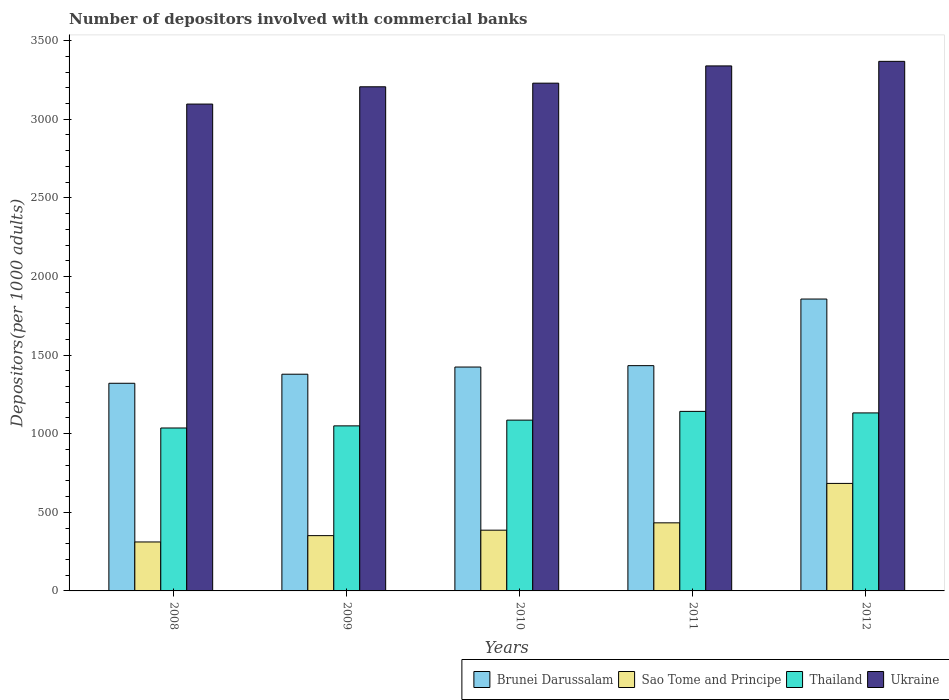How many groups of bars are there?
Your answer should be compact. 5. Are the number of bars per tick equal to the number of legend labels?
Give a very brief answer. Yes. Are the number of bars on each tick of the X-axis equal?
Your answer should be very brief. Yes. What is the label of the 1st group of bars from the left?
Your answer should be compact. 2008. In how many cases, is the number of bars for a given year not equal to the number of legend labels?
Your answer should be compact. 0. What is the number of depositors involved with commercial banks in Ukraine in 2009?
Your answer should be compact. 3206.64. Across all years, what is the maximum number of depositors involved with commercial banks in Brunei Darussalam?
Your answer should be very brief. 1856.6. Across all years, what is the minimum number of depositors involved with commercial banks in Sao Tome and Principe?
Your response must be concise. 311.37. In which year was the number of depositors involved with commercial banks in Thailand maximum?
Offer a very short reply. 2011. What is the total number of depositors involved with commercial banks in Ukraine in the graph?
Offer a very short reply. 1.62e+04. What is the difference between the number of depositors involved with commercial banks in Sao Tome and Principe in 2009 and that in 2010?
Provide a short and direct response. -34.67. What is the difference between the number of depositors involved with commercial banks in Ukraine in 2011 and the number of depositors involved with commercial banks in Brunei Darussalam in 2012?
Your answer should be compact. 1482.81. What is the average number of depositors involved with commercial banks in Brunei Darussalam per year?
Give a very brief answer. 1482.56. In the year 2010, what is the difference between the number of depositors involved with commercial banks in Thailand and number of depositors involved with commercial banks in Ukraine?
Your response must be concise. -2143.33. What is the ratio of the number of depositors involved with commercial banks in Thailand in 2009 to that in 2011?
Offer a very short reply. 0.92. Is the difference between the number of depositors involved with commercial banks in Thailand in 2008 and 2009 greater than the difference between the number of depositors involved with commercial banks in Ukraine in 2008 and 2009?
Offer a terse response. Yes. What is the difference between the highest and the second highest number of depositors involved with commercial banks in Ukraine?
Your answer should be compact. 28.98. What is the difference between the highest and the lowest number of depositors involved with commercial banks in Sao Tome and Principe?
Provide a short and direct response. 372.44. Is the sum of the number of depositors involved with commercial banks in Ukraine in 2010 and 2012 greater than the maximum number of depositors involved with commercial banks in Sao Tome and Principe across all years?
Your answer should be compact. Yes. What does the 1st bar from the left in 2009 represents?
Your answer should be very brief. Brunei Darussalam. What does the 2nd bar from the right in 2012 represents?
Make the answer very short. Thailand. Is it the case that in every year, the sum of the number of depositors involved with commercial banks in Brunei Darussalam and number of depositors involved with commercial banks in Thailand is greater than the number of depositors involved with commercial banks in Sao Tome and Principe?
Provide a succinct answer. Yes. What is the difference between two consecutive major ticks on the Y-axis?
Give a very brief answer. 500. Where does the legend appear in the graph?
Give a very brief answer. Bottom right. How many legend labels are there?
Make the answer very short. 4. How are the legend labels stacked?
Your answer should be very brief. Horizontal. What is the title of the graph?
Provide a succinct answer. Number of depositors involved with commercial banks. What is the label or title of the X-axis?
Keep it short and to the point. Years. What is the label or title of the Y-axis?
Your answer should be compact. Depositors(per 1000 adults). What is the Depositors(per 1000 adults) of Brunei Darussalam in 2008?
Give a very brief answer. 1320.81. What is the Depositors(per 1000 adults) of Sao Tome and Principe in 2008?
Provide a short and direct response. 311.37. What is the Depositors(per 1000 adults) in Thailand in 2008?
Make the answer very short. 1036.31. What is the Depositors(per 1000 adults) of Ukraine in 2008?
Your answer should be compact. 3096.67. What is the Depositors(per 1000 adults) in Brunei Darussalam in 2009?
Ensure brevity in your answer.  1378.46. What is the Depositors(per 1000 adults) in Sao Tome and Principe in 2009?
Your response must be concise. 351.71. What is the Depositors(per 1000 adults) in Thailand in 2009?
Ensure brevity in your answer.  1049.83. What is the Depositors(per 1000 adults) in Ukraine in 2009?
Offer a very short reply. 3206.64. What is the Depositors(per 1000 adults) in Brunei Darussalam in 2010?
Provide a short and direct response. 1424.06. What is the Depositors(per 1000 adults) in Sao Tome and Principe in 2010?
Your answer should be very brief. 386.38. What is the Depositors(per 1000 adults) of Thailand in 2010?
Offer a terse response. 1086.36. What is the Depositors(per 1000 adults) in Ukraine in 2010?
Keep it short and to the point. 3229.69. What is the Depositors(per 1000 adults) in Brunei Darussalam in 2011?
Provide a short and direct response. 1432.88. What is the Depositors(per 1000 adults) of Sao Tome and Principe in 2011?
Provide a short and direct response. 433.08. What is the Depositors(per 1000 adults) of Thailand in 2011?
Make the answer very short. 1142.03. What is the Depositors(per 1000 adults) of Ukraine in 2011?
Give a very brief answer. 3339.41. What is the Depositors(per 1000 adults) of Brunei Darussalam in 2012?
Offer a very short reply. 1856.6. What is the Depositors(per 1000 adults) of Sao Tome and Principe in 2012?
Offer a terse response. 683.81. What is the Depositors(per 1000 adults) of Thailand in 2012?
Make the answer very short. 1132.21. What is the Depositors(per 1000 adults) of Ukraine in 2012?
Your answer should be compact. 3368.39. Across all years, what is the maximum Depositors(per 1000 adults) of Brunei Darussalam?
Keep it short and to the point. 1856.6. Across all years, what is the maximum Depositors(per 1000 adults) in Sao Tome and Principe?
Provide a succinct answer. 683.81. Across all years, what is the maximum Depositors(per 1000 adults) of Thailand?
Ensure brevity in your answer.  1142.03. Across all years, what is the maximum Depositors(per 1000 adults) in Ukraine?
Offer a terse response. 3368.39. Across all years, what is the minimum Depositors(per 1000 adults) of Brunei Darussalam?
Give a very brief answer. 1320.81. Across all years, what is the minimum Depositors(per 1000 adults) in Sao Tome and Principe?
Offer a terse response. 311.37. Across all years, what is the minimum Depositors(per 1000 adults) in Thailand?
Offer a terse response. 1036.31. Across all years, what is the minimum Depositors(per 1000 adults) in Ukraine?
Offer a terse response. 3096.67. What is the total Depositors(per 1000 adults) in Brunei Darussalam in the graph?
Make the answer very short. 7412.8. What is the total Depositors(per 1000 adults) in Sao Tome and Principe in the graph?
Make the answer very short. 2166.35. What is the total Depositors(per 1000 adults) of Thailand in the graph?
Offer a very short reply. 5446.73. What is the total Depositors(per 1000 adults) of Ukraine in the graph?
Offer a terse response. 1.62e+04. What is the difference between the Depositors(per 1000 adults) of Brunei Darussalam in 2008 and that in 2009?
Ensure brevity in your answer.  -57.65. What is the difference between the Depositors(per 1000 adults) in Sao Tome and Principe in 2008 and that in 2009?
Ensure brevity in your answer.  -40.34. What is the difference between the Depositors(per 1000 adults) in Thailand in 2008 and that in 2009?
Your answer should be very brief. -13.52. What is the difference between the Depositors(per 1000 adults) in Ukraine in 2008 and that in 2009?
Ensure brevity in your answer.  -109.97. What is the difference between the Depositors(per 1000 adults) of Brunei Darussalam in 2008 and that in 2010?
Your response must be concise. -103.26. What is the difference between the Depositors(per 1000 adults) of Sao Tome and Principe in 2008 and that in 2010?
Your answer should be compact. -75.01. What is the difference between the Depositors(per 1000 adults) of Thailand in 2008 and that in 2010?
Make the answer very short. -50.05. What is the difference between the Depositors(per 1000 adults) of Ukraine in 2008 and that in 2010?
Your answer should be very brief. -133.02. What is the difference between the Depositors(per 1000 adults) in Brunei Darussalam in 2008 and that in 2011?
Ensure brevity in your answer.  -112.07. What is the difference between the Depositors(per 1000 adults) of Sao Tome and Principe in 2008 and that in 2011?
Make the answer very short. -121.71. What is the difference between the Depositors(per 1000 adults) of Thailand in 2008 and that in 2011?
Keep it short and to the point. -105.72. What is the difference between the Depositors(per 1000 adults) in Ukraine in 2008 and that in 2011?
Make the answer very short. -242.74. What is the difference between the Depositors(per 1000 adults) in Brunei Darussalam in 2008 and that in 2012?
Your response must be concise. -535.79. What is the difference between the Depositors(per 1000 adults) of Sao Tome and Principe in 2008 and that in 2012?
Provide a succinct answer. -372.44. What is the difference between the Depositors(per 1000 adults) in Thailand in 2008 and that in 2012?
Offer a terse response. -95.9. What is the difference between the Depositors(per 1000 adults) in Ukraine in 2008 and that in 2012?
Ensure brevity in your answer.  -271.72. What is the difference between the Depositors(per 1000 adults) of Brunei Darussalam in 2009 and that in 2010?
Ensure brevity in your answer.  -45.61. What is the difference between the Depositors(per 1000 adults) of Sao Tome and Principe in 2009 and that in 2010?
Your answer should be very brief. -34.67. What is the difference between the Depositors(per 1000 adults) of Thailand in 2009 and that in 2010?
Give a very brief answer. -36.53. What is the difference between the Depositors(per 1000 adults) of Ukraine in 2009 and that in 2010?
Provide a succinct answer. -23.06. What is the difference between the Depositors(per 1000 adults) of Brunei Darussalam in 2009 and that in 2011?
Make the answer very short. -54.42. What is the difference between the Depositors(per 1000 adults) of Sao Tome and Principe in 2009 and that in 2011?
Your answer should be very brief. -81.37. What is the difference between the Depositors(per 1000 adults) of Thailand in 2009 and that in 2011?
Ensure brevity in your answer.  -92.2. What is the difference between the Depositors(per 1000 adults) of Ukraine in 2009 and that in 2011?
Your answer should be compact. -132.77. What is the difference between the Depositors(per 1000 adults) in Brunei Darussalam in 2009 and that in 2012?
Ensure brevity in your answer.  -478.14. What is the difference between the Depositors(per 1000 adults) in Sao Tome and Principe in 2009 and that in 2012?
Give a very brief answer. -332.1. What is the difference between the Depositors(per 1000 adults) of Thailand in 2009 and that in 2012?
Ensure brevity in your answer.  -82.38. What is the difference between the Depositors(per 1000 adults) of Ukraine in 2009 and that in 2012?
Your answer should be compact. -161.75. What is the difference between the Depositors(per 1000 adults) in Brunei Darussalam in 2010 and that in 2011?
Keep it short and to the point. -8.82. What is the difference between the Depositors(per 1000 adults) of Sao Tome and Principe in 2010 and that in 2011?
Ensure brevity in your answer.  -46.7. What is the difference between the Depositors(per 1000 adults) of Thailand in 2010 and that in 2011?
Your response must be concise. -55.66. What is the difference between the Depositors(per 1000 adults) in Ukraine in 2010 and that in 2011?
Give a very brief answer. -109.71. What is the difference between the Depositors(per 1000 adults) in Brunei Darussalam in 2010 and that in 2012?
Your answer should be compact. -432.53. What is the difference between the Depositors(per 1000 adults) in Sao Tome and Principe in 2010 and that in 2012?
Make the answer very short. -297.44. What is the difference between the Depositors(per 1000 adults) in Thailand in 2010 and that in 2012?
Give a very brief answer. -45.84. What is the difference between the Depositors(per 1000 adults) in Ukraine in 2010 and that in 2012?
Your answer should be compact. -138.7. What is the difference between the Depositors(per 1000 adults) of Brunei Darussalam in 2011 and that in 2012?
Your answer should be compact. -423.72. What is the difference between the Depositors(per 1000 adults) of Sao Tome and Principe in 2011 and that in 2012?
Offer a very short reply. -250.73. What is the difference between the Depositors(per 1000 adults) of Thailand in 2011 and that in 2012?
Ensure brevity in your answer.  9.82. What is the difference between the Depositors(per 1000 adults) in Ukraine in 2011 and that in 2012?
Your answer should be compact. -28.98. What is the difference between the Depositors(per 1000 adults) of Brunei Darussalam in 2008 and the Depositors(per 1000 adults) of Sao Tome and Principe in 2009?
Give a very brief answer. 969.09. What is the difference between the Depositors(per 1000 adults) in Brunei Darussalam in 2008 and the Depositors(per 1000 adults) in Thailand in 2009?
Ensure brevity in your answer.  270.98. What is the difference between the Depositors(per 1000 adults) in Brunei Darussalam in 2008 and the Depositors(per 1000 adults) in Ukraine in 2009?
Make the answer very short. -1885.83. What is the difference between the Depositors(per 1000 adults) in Sao Tome and Principe in 2008 and the Depositors(per 1000 adults) in Thailand in 2009?
Keep it short and to the point. -738.46. What is the difference between the Depositors(per 1000 adults) of Sao Tome and Principe in 2008 and the Depositors(per 1000 adults) of Ukraine in 2009?
Offer a terse response. -2895.27. What is the difference between the Depositors(per 1000 adults) of Thailand in 2008 and the Depositors(per 1000 adults) of Ukraine in 2009?
Provide a succinct answer. -2170.33. What is the difference between the Depositors(per 1000 adults) in Brunei Darussalam in 2008 and the Depositors(per 1000 adults) in Sao Tome and Principe in 2010?
Ensure brevity in your answer.  934.43. What is the difference between the Depositors(per 1000 adults) of Brunei Darussalam in 2008 and the Depositors(per 1000 adults) of Thailand in 2010?
Make the answer very short. 234.44. What is the difference between the Depositors(per 1000 adults) of Brunei Darussalam in 2008 and the Depositors(per 1000 adults) of Ukraine in 2010?
Your response must be concise. -1908.89. What is the difference between the Depositors(per 1000 adults) in Sao Tome and Principe in 2008 and the Depositors(per 1000 adults) in Thailand in 2010?
Offer a terse response. -774.99. What is the difference between the Depositors(per 1000 adults) of Sao Tome and Principe in 2008 and the Depositors(per 1000 adults) of Ukraine in 2010?
Give a very brief answer. -2918.32. What is the difference between the Depositors(per 1000 adults) in Thailand in 2008 and the Depositors(per 1000 adults) in Ukraine in 2010?
Your answer should be very brief. -2193.38. What is the difference between the Depositors(per 1000 adults) of Brunei Darussalam in 2008 and the Depositors(per 1000 adults) of Sao Tome and Principe in 2011?
Give a very brief answer. 887.72. What is the difference between the Depositors(per 1000 adults) in Brunei Darussalam in 2008 and the Depositors(per 1000 adults) in Thailand in 2011?
Your answer should be very brief. 178.78. What is the difference between the Depositors(per 1000 adults) in Brunei Darussalam in 2008 and the Depositors(per 1000 adults) in Ukraine in 2011?
Your answer should be compact. -2018.6. What is the difference between the Depositors(per 1000 adults) in Sao Tome and Principe in 2008 and the Depositors(per 1000 adults) in Thailand in 2011?
Your answer should be compact. -830.65. What is the difference between the Depositors(per 1000 adults) in Sao Tome and Principe in 2008 and the Depositors(per 1000 adults) in Ukraine in 2011?
Provide a succinct answer. -3028.03. What is the difference between the Depositors(per 1000 adults) of Thailand in 2008 and the Depositors(per 1000 adults) of Ukraine in 2011?
Offer a very short reply. -2303.1. What is the difference between the Depositors(per 1000 adults) in Brunei Darussalam in 2008 and the Depositors(per 1000 adults) in Sao Tome and Principe in 2012?
Your answer should be compact. 636.99. What is the difference between the Depositors(per 1000 adults) of Brunei Darussalam in 2008 and the Depositors(per 1000 adults) of Thailand in 2012?
Ensure brevity in your answer.  188.6. What is the difference between the Depositors(per 1000 adults) of Brunei Darussalam in 2008 and the Depositors(per 1000 adults) of Ukraine in 2012?
Your response must be concise. -2047.58. What is the difference between the Depositors(per 1000 adults) of Sao Tome and Principe in 2008 and the Depositors(per 1000 adults) of Thailand in 2012?
Offer a very short reply. -820.84. What is the difference between the Depositors(per 1000 adults) of Sao Tome and Principe in 2008 and the Depositors(per 1000 adults) of Ukraine in 2012?
Offer a terse response. -3057.02. What is the difference between the Depositors(per 1000 adults) in Thailand in 2008 and the Depositors(per 1000 adults) in Ukraine in 2012?
Provide a short and direct response. -2332.08. What is the difference between the Depositors(per 1000 adults) of Brunei Darussalam in 2009 and the Depositors(per 1000 adults) of Sao Tome and Principe in 2010?
Offer a terse response. 992.08. What is the difference between the Depositors(per 1000 adults) of Brunei Darussalam in 2009 and the Depositors(per 1000 adults) of Thailand in 2010?
Give a very brief answer. 292.09. What is the difference between the Depositors(per 1000 adults) in Brunei Darussalam in 2009 and the Depositors(per 1000 adults) in Ukraine in 2010?
Your answer should be very brief. -1851.24. What is the difference between the Depositors(per 1000 adults) of Sao Tome and Principe in 2009 and the Depositors(per 1000 adults) of Thailand in 2010?
Give a very brief answer. -734.65. What is the difference between the Depositors(per 1000 adults) in Sao Tome and Principe in 2009 and the Depositors(per 1000 adults) in Ukraine in 2010?
Your response must be concise. -2877.98. What is the difference between the Depositors(per 1000 adults) of Thailand in 2009 and the Depositors(per 1000 adults) of Ukraine in 2010?
Offer a very short reply. -2179.86. What is the difference between the Depositors(per 1000 adults) in Brunei Darussalam in 2009 and the Depositors(per 1000 adults) in Sao Tome and Principe in 2011?
Provide a succinct answer. 945.37. What is the difference between the Depositors(per 1000 adults) in Brunei Darussalam in 2009 and the Depositors(per 1000 adults) in Thailand in 2011?
Your response must be concise. 236.43. What is the difference between the Depositors(per 1000 adults) in Brunei Darussalam in 2009 and the Depositors(per 1000 adults) in Ukraine in 2011?
Keep it short and to the point. -1960.95. What is the difference between the Depositors(per 1000 adults) of Sao Tome and Principe in 2009 and the Depositors(per 1000 adults) of Thailand in 2011?
Your answer should be compact. -790.31. What is the difference between the Depositors(per 1000 adults) in Sao Tome and Principe in 2009 and the Depositors(per 1000 adults) in Ukraine in 2011?
Ensure brevity in your answer.  -2987.69. What is the difference between the Depositors(per 1000 adults) of Thailand in 2009 and the Depositors(per 1000 adults) of Ukraine in 2011?
Your answer should be very brief. -2289.58. What is the difference between the Depositors(per 1000 adults) of Brunei Darussalam in 2009 and the Depositors(per 1000 adults) of Sao Tome and Principe in 2012?
Provide a short and direct response. 694.64. What is the difference between the Depositors(per 1000 adults) in Brunei Darussalam in 2009 and the Depositors(per 1000 adults) in Thailand in 2012?
Your response must be concise. 246.25. What is the difference between the Depositors(per 1000 adults) in Brunei Darussalam in 2009 and the Depositors(per 1000 adults) in Ukraine in 2012?
Your answer should be very brief. -1989.93. What is the difference between the Depositors(per 1000 adults) in Sao Tome and Principe in 2009 and the Depositors(per 1000 adults) in Thailand in 2012?
Ensure brevity in your answer.  -780.49. What is the difference between the Depositors(per 1000 adults) in Sao Tome and Principe in 2009 and the Depositors(per 1000 adults) in Ukraine in 2012?
Give a very brief answer. -3016.68. What is the difference between the Depositors(per 1000 adults) in Thailand in 2009 and the Depositors(per 1000 adults) in Ukraine in 2012?
Give a very brief answer. -2318.56. What is the difference between the Depositors(per 1000 adults) in Brunei Darussalam in 2010 and the Depositors(per 1000 adults) in Sao Tome and Principe in 2011?
Provide a short and direct response. 990.98. What is the difference between the Depositors(per 1000 adults) of Brunei Darussalam in 2010 and the Depositors(per 1000 adults) of Thailand in 2011?
Your answer should be compact. 282.04. What is the difference between the Depositors(per 1000 adults) in Brunei Darussalam in 2010 and the Depositors(per 1000 adults) in Ukraine in 2011?
Your response must be concise. -1915.34. What is the difference between the Depositors(per 1000 adults) of Sao Tome and Principe in 2010 and the Depositors(per 1000 adults) of Thailand in 2011?
Your answer should be very brief. -755.65. What is the difference between the Depositors(per 1000 adults) of Sao Tome and Principe in 2010 and the Depositors(per 1000 adults) of Ukraine in 2011?
Ensure brevity in your answer.  -2953.03. What is the difference between the Depositors(per 1000 adults) in Thailand in 2010 and the Depositors(per 1000 adults) in Ukraine in 2011?
Offer a very short reply. -2253.04. What is the difference between the Depositors(per 1000 adults) in Brunei Darussalam in 2010 and the Depositors(per 1000 adults) in Sao Tome and Principe in 2012?
Your response must be concise. 740.25. What is the difference between the Depositors(per 1000 adults) in Brunei Darussalam in 2010 and the Depositors(per 1000 adults) in Thailand in 2012?
Ensure brevity in your answer.  291.86. What is the difference between the Depositors(per 1000 adults) in Brunei Darussalam in 2010 and the Depositors(per 1000 adults) in Ukraine in 2012?
Your response must be concise. -1944.33. What is the difference between the Depositors(per 1000 adults) in Sao Tome and Principe in 2010 and the Depositors(per 1000 adults) in Thailand in 2012?
Offer a very short reply. -745.83. What is the difference between the Depositors(per 1000 adults) of Sao Tome and Principe in 2010 and the Depositors(per 1000 adults) of Ukraine in 2012?
Provide a short and direct response. -2982.01. What is the difference between the Depositors(per 1000 adults) in Thailand in 2010 and the Depositors(per 1000 adults) in Ukraine in 2012?
Give a very brief answer. -2282.03. What is the difference between the Depositors(per 1000 adults) of Brunei Darussalam in 2011 and the Depositors(per 1000 adults) of Sao Tome and Principe in 2012?
Give a very brief answer. 749.07. What is the difference between the Depositors(per 1000 adults) in Brunei Darussalam in 2011 and the Depositors(per 1000 adults) in Thailand in 2012?
Your response must be concise. 300.67. What is the difference between the Depositors(per 1000 adults) of Brunei Darussalam in 2011 and the Depositors(per 1000 adults) of Ukraine in 2012?
Your answer should be compact. -1935.51. What is the difference between the Depositors(per 1000 adults) of Sao Tome and Principe in 2011 and the Depositors(per 1000 adults) of Thailand in 2012?
Your answer should be compact. -699.12. What is the difference between the Depositors(per 1000 adults) in Sao Tome and Principe in 2011 and the Depositors(per 1000 adults) in Ukraine in 2012?
Ensure brevity in your answer.  -2935.31. What is the difference between the Depositors(per 1000 adults) in Thailand in 2011 and the Depositors(per 1000 adults) in Ukraine in 2012?
Your response must be concise. -2226.36. What is the average Depositors(per 1000 adults) in Brunei Darussalam per year?
Provide a short and direct response. 1482.56. What is the average Depositors(per 1000 adults) of Sao Tome and Principe per year?
Provide a short and direct response. 433.27. What is the average Depositors(per 1000 adults) of Thailand per year?
Your answer should be compact. 1089.35. What is the average Depositors(per 1000 adults) of Ukraine per year?
Your answer should be compact. 3248.16. In the year 2008, what is the difference between the Depositors(per 1000 adults) of Brunei Darussalam and Depositors(per 1000 adults) of Sao Tome and Principe?
Your answer should be very brief. 1009.43. In the year 2008, what is the difference between the Depositors(per 1000 adults) of Brunei Darussalam and Depositors(per 1000 adults) of Thailand?
Make the answer very short. 284.5. In the year 2008, what is the difference between the Depositors(per 1000 adults) in Brunei Darussalam and Depositors(per 1000 adults) in Ukraine?
Your answer should be very brief. -1775.86. In the year 2008, what is the difference between the Depositors(per 1000 adults) of Sao Tome and Principe and Depositors(per 1000 adults) of Thailand?
Give a very brief answer. -724.94. In the year 2008, what is the difference between the Depositors(per 1000 adults) of Sao Tome and Principe and Depositors(per 1000 adults) of Ukraine?
Ensure brevity in your answer.  -2785.3. In the year 2008, what is the difference between the Depositors(per 1000 adults) in Thailand and Depositors(per 1000 adults) in Ukraine?
Provide a short and direct response. -2060.36. In the year 2009, what is the difference between the Depositors(per 1000 adults) of Brunei Darussalam and Depositors(per 1000 adults) of Sao Tome and Principe?
Keep it short and to the point. 1026.74. In the year 2009, what is the difference between the Depositors(per 1000 adults) of Brunei Darussalam and Depositors(per 1000 adults) of Thailand?
Provide a short and direct response. 328.63. In the year 2009, what is the difference between the Depositors(per 1000 adults) in Brunei Darussalam and Depositors(per 1000 adults) in Ukraine?
Your response must be concise. -1828.18. In the year 2009, what is the difference between the Depositors(per 1000 adults) in Sao Tome and Principe and Depositors(per 1000 adults) in Thailand?
Provide a short and direct response. -698.12. In the year 2009, what is the difference between the Depositors(per 1000 adults) in Sao Tome and Principe and Depositors(per 1000 adults) in Ukraine?
Make the answer very short. -2854.92. In the year 2009, what is the difference between the Depositors(per 1000 adults) in Thailand and Depositors(per 1000 adults) in Ukraine?
Provide a short and direct response. -2156.81. In the year 2010, what is the difference between the Depositors(per 1000 adults) in Brunei Darussalam and Depositors(per 1000 adults) in Sao Tome and Principe?
Keep it short and to the point. 1037.68. In the year 2010, what is the difference between the Depositors(per 1000 adults) of Brunei Darussalam and Depositors(per 1000 adults) of Thailand?
Give a very brief answer. 337.7. In the year 2010, what is the difference between the Depositors(per 1000 adults) of Brunei Darussalam and Depositors(per 1000 adults) of Ukraine?
Make the answer very short. -1805.63. In the year 2010, what is the difference between the Depositors(per 1000 adults) of Sao Tome and Principe and Depositors(per 1000 adults) of Thailand?
Ensure brevity in your answer.  -699.98. In the year 2010, what is the difference between the Depositors(per 1000 adults) of Sao Tome and Principe and Depositors(per 1000 adults) of Ukraine?
Provide a short and direct response. -2843.32. In the year 2010, what is the difference between the Depositors(per 1000 adults) of Thailand and Depositors(per 1000 adults) of Ukraine?
Provide a succinct answer. -2143.33. In the year 2011, what is the difference between the Depositors(per 1000 adults) of Brunei Darussalam and Depositors(per 1000 adults) of Sao Tome and Principe?
Provide a succinct answer. 999.8. In the year 2011, what is the difference between the Depositors(per 1000 adults) of Brunei Darussalam and Depositors(per 1000 adults) of Thailand?
Offer a terse response. 290.85. In the year 2011, what is the difference between the Depositors(per 1000 adults) of Brunei Darussalam and Depositors(per 1000 adults) of Ukraine?
Give a very brief answer. -1906.53. In the year 2011, what is the difference between the Depositors(per 1000 adults) of Sao Tome and Principe and Depositors(per 1000 adults) of Thailand?
Keep it short and to the point. -708.94. In the year 2011, what is the difference between the Depositors(per 1000 adults) of Sao Tome and Principe and Depositors(per 1000 adults) of Ukraine?
Your answer should be very brief. -2906.32. In the year 2011, what is the difference between the Depositors(per 1000 adults) in Thailand and Depositors(per 1000 adults) in Ukraine?
Offer a very short reply. -2197.38. In the year 2012, what is the difference between the Depositors(per 1000 adults) of Brunei Darussalam and Depositors(per 1000 adults) of Sao Tome and Principe?
Provide a short and direct response. 1172.78. In the year 2012, what is the difference between the Depositors(per 1000 adults) in Brunei Darussalam and Depositors(per 1000 adults) in Thailand?
Keep it short and to the point. 724.39. In the year 2012, what is the difference between the Depositors(per 1000 adults) in Brunei Darussalam and Depositors(per 1000 adults) in Ukraine?
Your response must be concise. -1511.79. In the year 2012, what is the difference between the Depositors(per 1000 adults) of Sao Tome and Principe and Depositors(per 1000 adults) of Thailand?
Your answer should be compact. -448.39. In the year 2012, what is the difference between the Depositors(per 1000 adults) of Sao Tome and Principe and Depositors(per 1000 adults) of Ukraine?
Offer a very short reply. -2684.58. In the year 2012, what is the difference between the Depositors(per 1000 adults) in Thailand and Depositors(per 1000 adults) in Ukraine?
Ensure brevity in your answer.  -2236.18. What is the ratio of the Depositors(per 1000 adults) in Brunei Darussalam in 2008 to that in 2009?
Your response must be concise. 0.96. What is the ratio of the Depositors(per 1000 adults) in Sao Tome and Principe in 2008 to that in 2009?
Your response must be concise. 0.89. What is the ratio of the Depositors(per 1000 adults) in Thailand in 2008 to that in 2009?
Your answer should be compact. 0.99. What is the ratio of the Depositors(per 1000 adults) of Ukraine in 2008 to that in 2009?
Provide a short and direct response. 0.97. What is the ratio of the Depositors(per 1000 adults) of Brunei Darussalam in 2008 to that in 2010?
Keep it short and to the point. 0.93. What is the ratio of the Depositors(per 1000 adults) in Sao Tome and Principe in 2008 to that in 2010?
Ensure brevity in your answer.  0.81. What is the ratio of the Depositors(per 1000 adults) in Thailand in 2008 to that in 2010?
Offer a terse response. 0.95. What is the ratio of the Depositors(per 1000 adults) of Ukraine in 2008 to that in 2010?
Your response must be concise. 0.96. What is the ratio of the Depositors(per 1000 adults) of Brunei Darussalam in 2008 to that in 2011?
Make the answer very short. 0.92. What is the ratio of the Depositors(per 1000 adults) in Sao Tome and Principe in 2008 to that in 2011?
Ensure brevity in your answer.  0.72. What is the ratio of the Depositors(per 1000 adults) in Thailand in 2008 to that in 2011?
Ensure brevity in your answer.  0.91. What is the ratio of the Depositors(per 1000 adults) of Ukraine in 2008 to that in 2011?
Keep it short and to the point. 0.93. What is the ratio of the Depositors(per 1000 adults) of Brunei Darussalam in 2008 to that in 2012?
Keep it short and to the point. 0.71. What is the ratio of the Depositors(per 1000 adults) in Sao Tome and Principe in 2008 to that in 2012?
Offer a very short reply. 0.46. What is the ratio of the Depositors(per 1000 adults) in Thailand in 2008 to that in 2012?
Provide a succinct answer. 0.92. What is the ratio of the Depositors(per 1000 adults) of Ukraine in 2008 to that in 2012?
Your answer should be very brief. 0.92. What is the ratio of the Depositors(per 1000 adults) in Sao Tome and Principe in 2009 to that in 2010?
Keep it short and to the point. 0.91. What is the ratio of the Depositors(per 1000 adults) in Thailand in 2009 to that in 2010?
Your answer should be very brief. 0.97. What is the ratio of the Depositors(per 1000 adults) in Ukraine in 2009 to that in 2010?
Offer a terse response. 0.99. What is the ratio of the Depositors(per 1000 adults) of Sao Tome and Principe in 2009 to that in 2011?
Your response must be concise. 0.81. What is the ratio of the Depositors(per 1000 adults) of Thailand in 2009 to that in 2011?
Your answer should be very brief. 0.92. What is the ratio of the Depositors(per 1000 adults) in Ukraine in 2009 to that in 2011?
Give a very brief answer. 0.96. What is the ratio of the Depositors(per 1000 adults) of Brunei Darussalam in 2009 to that in 2012?
Offer a terse response. 0.74. What is the ratio of the Depositors(per 1000 adults) in Sao Tome and Principe in 2009 to that in 2012?
Offer a terse response. 0.51. What is the ratio of the Depositors(per 1000 adults) of Thailand in 2009 to that in 2012?
Offer a terse response. 0.93. What is the ratio of the Depositors(per 1000 adults) of Ukraine in 2009 to that in 2012?
Offer a very short reply. 0.95. What is the ratio of the Depositors(per 1000 adults) of Brunei Darussalam in 2010 to that in 2011?
Make the answer very short. 0.99. What is the ratio of the Depositors(per 1000 adults) in Sao Tome and Principe in 2010 to that in 2011?
Give a very brief answer. 0.89. What is the ratio of the Depositors(per 1000 adults) in Thailand in 2010 to that in 2011?
Keep it short and to the point. 0.95. What is the ratio of the Depositors(per 1000 adults) in Ukraine in 2010 to that in 2011?
Make the answer very short. 0.97. What is the ratio of the Depositors(per 1000 adults) in Brunei Darussalam in 2010 to that in 2012?
Make the answer very short. 0.77. What is the ratio of the Depositors(per 1000 adults) of Sao Tome and Principe in 2010 to that in 2012?
Make the answer very short. 0.56. What is the ratio of the Depositors(per 1000 adults) of Thailand in 2010 to that in 2012?
Ensure brevity in your answer.  0.96. What is the ratio of the Depositors(per 1000 adults) of Ukraine in 2010 to that in 2012?
Provide a short and direct response. 0.96. What is the ratio of the Depositors(per 1000 adults) in Brunei Darussalam in 2011 to that in 2012?
Your response must be concise. 0.77. What is the ratio of the Depositors(per 1000 adults) in Sao Tome and Principe in 2011 to that in 2012?
Offer a terse response. 0.63. What is the ratio of the Depositors(per 1000 adults) in Thailand in 2011 to that in 2012?
Give a very brief answer. 1.01. What is the difference between the highest and the second highest Depositors(per 1000 adults) in Brunei Darussalam?
Offer a very short reply. 423.72. What is the difference between the highest and the second highest Depositors(per 1000 adults) of Sao Tome and Principe?
Your answer should be compact. 250.73. What is the difference between the highest and the second highest Depositors(per 1000 adults) in Thailand?
Your answer should be compact. 9.82. What is the difference between the highest and the second highest Depositors(per 1000 adults) in Ukraine?
Your response must be concise. 28.98. What is the difference between the highest and the lowest Depositors(per 1000 adults) in Brunei Darussalam?
Your answer should be compact. 535.79. What is the difference between the highest and the lowest Depositors(per 1000 adults) in Sao Tome and Principe?
Provide a short and direct response. 372.44. What is the difference between the highest and the lowest Depositors(per 1000 adults) in Thailand?
Offer a very short reply. 105.72. What is the difference between the highest and the lowest Depositors(per 1000 adults) of Ukraine?
Offer a very short reply. 271.72. 